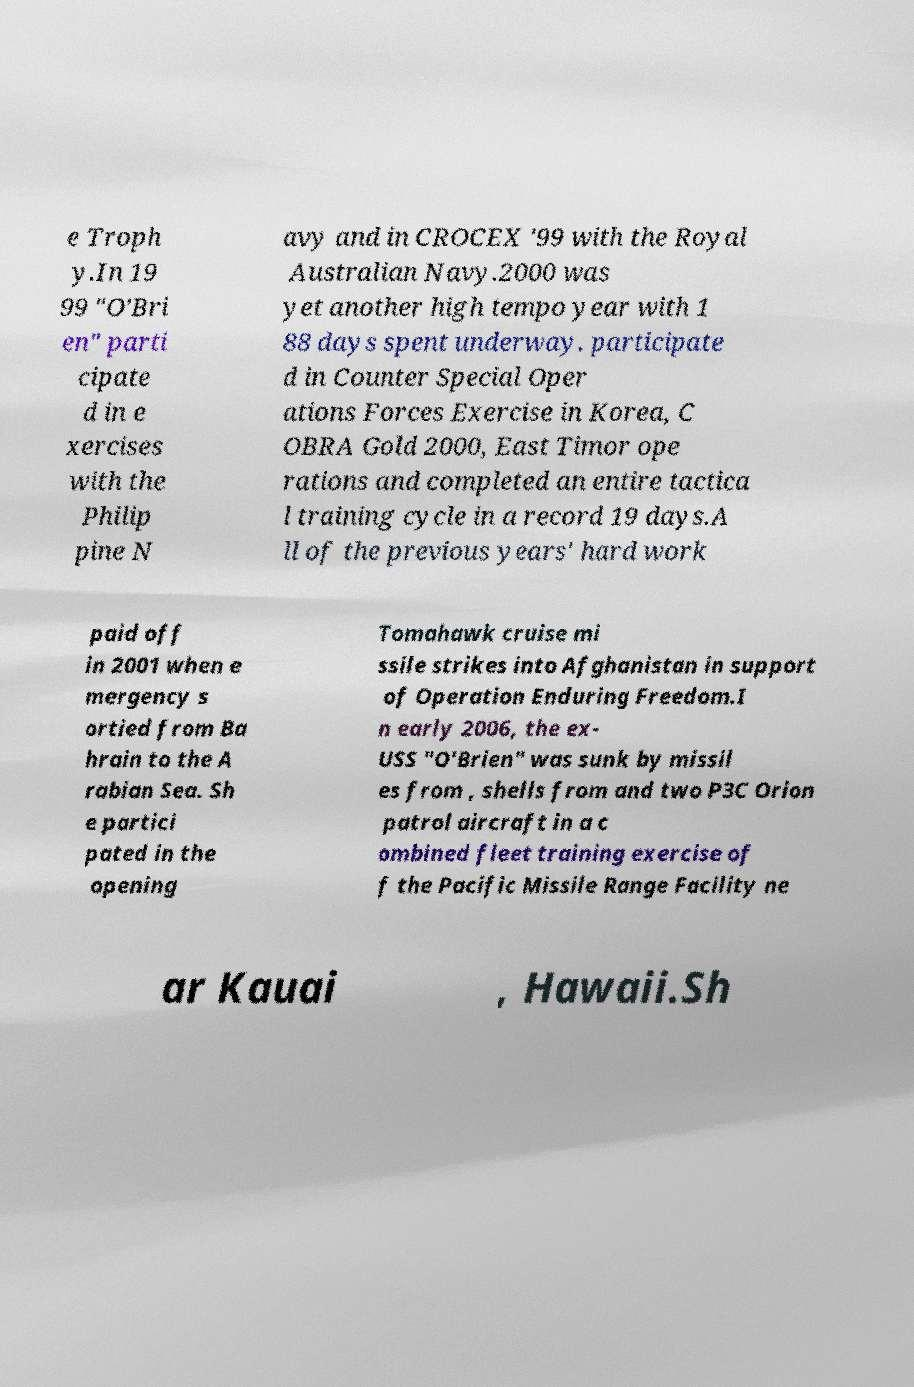Please identify and transcribe the text found in this image. e Troph y.In 19 99 "O'Bri en" parti cipate d in e xercises with the Philip pine N avy and in CROCEX '99 with the Royal Australian Navy.2000 was yet another high tempo year with 1 88 days spent underway. participate d in Counter Special Oper ations Forces Exercise in Korea, C OBRA Gold 2000, East Timor ope rations and completed an entire tactica l training cycle in a record 19 days.A ll of the previous years' hard work paid off in 2001 when e mergency s ortied from Ba hrain to the A rabian Sea. Sh e partici pated in the opening Tomahawk cruise mi ssile strikes into Afghanistan in support of Operation Enduring Freedom.I n early 2006, the ex- USS "O'Brien" was sunk by missil es from , shells from and two P3C Orion patrol aircraft in a c ombined fleet training exercise of f the Pacific Missile Range Facility ne ar Kauai , Hawaii.Sh 